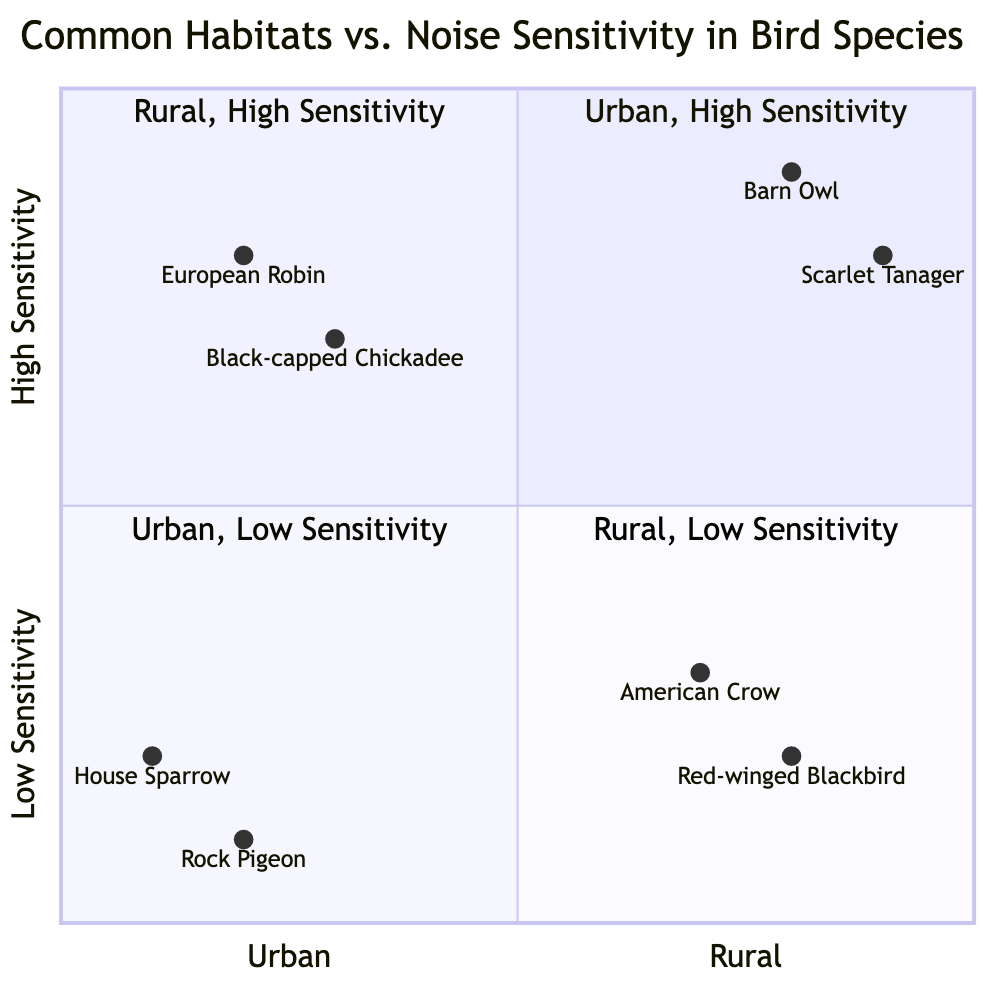What bird species is in the Urban-High Sensitivity quadrant? The diagram indicates that the Urban-High Sensitivity quadrant includes the European Robin and the Black-capped Chickadee.
Answer: European Robin, Black-capped Chickadee Which species is least sensitive to noise in urban areas? Reviewing the Urban-Low Sensitivity quadrant, the House Sparrow and Rock Pigeon are found there. Among these, the one more associated with busy urban settings is the House Sparrow.
Answer: House Sparrow How many species are found in the Rural-High Sensitivity quadrant? The Rural-High Sensitivity quadrant contains two species: Barn Owl and Scarlet Tanager.
Answer: 2 Which species tolerates noise from farming equipment? The Red-winged Blackbird appears in the Rural-Low Sensitivity quadrant and is mentioned as tolerating noise from farming equipment.
Answer: Red-winged Blackbird What is the common behavior of the Barn Owl? The details in the Rural-High Sensitivity quadrant state that the Barn Owl hunts in quiet farmlands.
Answer: Hunts in quiet farmlands Which quadrant contains a species that thrives in busy city centers? The Urban-Low Sensitivity quadrant contains the House Sparrow, which is noted to thrive in busy city centers.
Answer: Urban-Low Sensitivity What is the common behavior of the Scarlet Tanager? The Scarlet Tanager is noted to prefer the silence of deep woodlands according to the Rural-High Sensitivity quadrant information.
Answer: Prefers silence of deep woodlands How does the Black-capped Chickadee respond to noise disturbances? According to the data in the Urban-High Sensitivity quadrant, the Black-capped Chickadee is sensitive to minor noise disturbances.
Answer: Sensitive to minor noise disturbances 